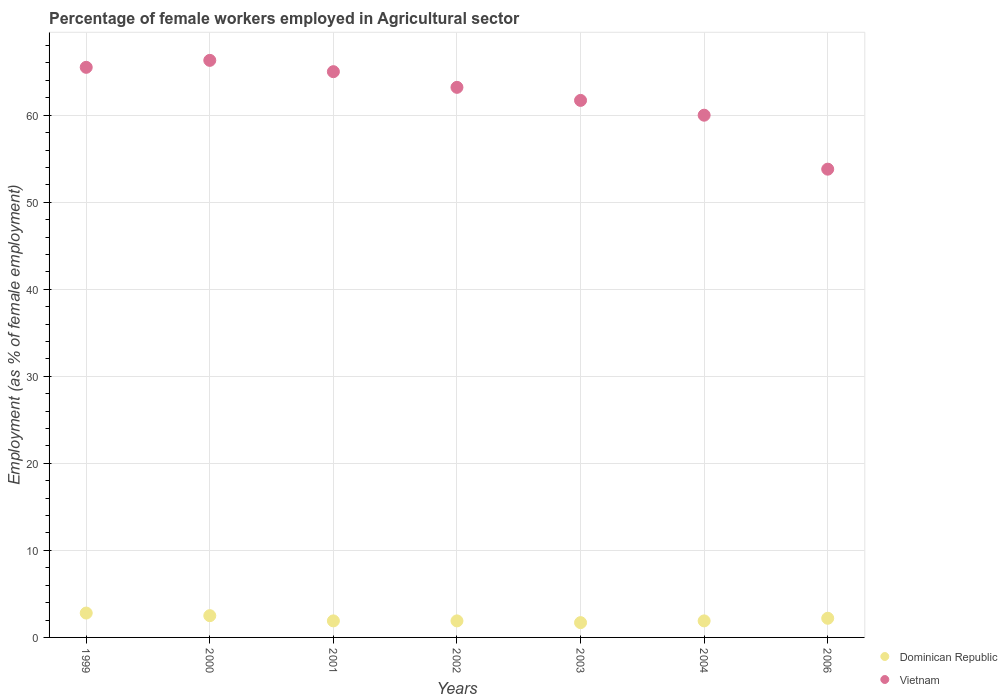How many different coloured dotlines are there?
Provide a short and direct response. 2. Is the number of dotlines equal to the number of legend labels?
Offer a terse response. Yes. What is the percentage of females employed in Agricultural sector in Dominican Republic in 2002?
Your answer should be compact. 1.9. Across all years, what is the maximum percentage of females employed in Agricultural sector in Dominican Republic?
Give a very brief answer. 2.8. Across all years, what is the minimum percentage of females employed in Agricultural sector in Vietnam?
Ensure brevity in your answer.  53.8. What is the total percentage of females employed in Agricultural sector in Dominican Republic in the graph?
Your answer should be very brief. 14.9. What is the difference between the percentage of females employed in Agricultural sector in Vietnam in 2000 and that in 2003?
Provide a succinct answer. 4.6. What is the difference between the percentage of females employed in Agricultural sector in Dominican Republic in 2006 and the percentage of females employed in Agricultural sector in Vietnam in 2003?
Your answer should be compact. -59.5. What is the average percentage of females employed in Agricultural sector in Dominican Republic per year?
Offer a very short reply. 2.13. In the year 2002, what is the difference between the percentage of females employed in Agricultural sector in Dominican Republic and percentage of females employed in Agricultural sector in Vietnam?
Provide a short and direct response. -61.3. What is the ratio of the percentage of females employed in Agricultural sector in Vietnam in 2003 to that in 2004?
Your answer should be compact. 1.03. What is the difference between the highest and the second highest percentage of females employed in Agricultural sector in Vietnam?
Make the answer very short. 0.8. What is the difference between the highest and the lowest percentage of females employed in Agricultural sector in Dominican Republic?
Keep it short and to the point. 1.1. In how many years, is the percentage of females employed in Agricultural sector in Dominican Republic greater than the average percentage of females employed in Agricultural sector in Dominican Republic taken over all years?
Provide a short and direct response. 3. Is the sum of the percentage of females employed in Agricultural sector in Vietnam in 1999 and 2006 greater than the maximum percentage of females employed in Agricultural sector in Dominican Republic across all years?
Offer a terse response. Yes. Is the percentage of females employed in Agricultural sector in Dominican Republic strictly greater than the percentage of females employed in Agricultural sector in Vietnam over the years?
Your answer should be compact. No. Is the percentage of females employed in Agricultural sector in Dominican Republic strictly less than the percentage of females employed in Agricultural sector in Vietnam over the years?
Your answer should be very brief. Yes. How many years are there in the graph?
Offer a very short reply. 7. Does the graph contain any zero values?
Ensure brevity in your answer.  No. Does the graph contain grids?
Ensure brevity in your answer.  Yes. Where does the legend appear in the graph?
Ensure brevity in your answer.  Bottom right. How many legend labels are there?
Ensure brevity in your answer.  2. What is the title of the graph?
Your response must be concise. Percentage of female workers employed in Agricultural sector. What is the label or title of the Y-axis?
Provide a short and direct response. Employment (as % of female employment). What is the Employment (as % of female employment) in Dominican Republic in 1999?
Ensure brevity in your answer.  2.8. What is the Employment (as % of female employment) of Vietnam in 1999?
Keep it short and to the point. 65.5. What is the Employment (as % of female employment) of Dominican Republic in 2000?
Your response must be concise. 2.5. What is the Employment (as % of female employment) in Vietnam in 2000?
Make the answer very short. 66.3. What is the Employment (as % of female employment) in Dominican Republic in 2001?
Your response must be concise. 1.9. What is the Employment (as % of female employment) of Dominican Republic in 2002?
Your answer should be very brief. 1.9. What is the Employment (as % of female employment) in Vietnam in 2002?
Your answer should be very brief. 63.2. What is the Employment (as % of female employment) of Dominican Republic in 2003?
Keep it short and to the point. 1.7. What is the Employment (as % of female employment) of Vietnam in 2003?
Ensure brevity in your answer.  61.7. What is the Employment (as % of female employment) of Dominican Republic in 2004?
Provide a short and direct response. 1.9. What is the Employment (as % of female employment) in Vietnam in 2004?
Offer a terse response. 60. What is the Employment (as % of female employment) of Dominican Republic in 2006?
Offer a terse response. 2.2. What is the Employment (as % of female employment) of Vietnam in 2006?
Your response must be concise. 53.8. Across all years, what is the maximum Employment (as % of female employment) of Dominican Republic?
Keep it short and to the point. 2.8. Across all years, what is the maximum Employment (as % of female employment) in Vietnam?
Make the answer very short. 66.3. Across all years, what is the minimum Employment (as % of female employment) in Dominican Republic?
Ensure brevity in your answer.  1.7. Across all years, what is the minimum Employment (as % of female employment) of Vietnam?
Keep it short and to the point. 53.8. What is the total Employment (as % of female employment) of Vietnam in the graph?
Provide a succinct answer. 435.5. What is the difference between the Employment (as % of female employment) in Dominican Republic in 1999 and that in 2001?
Provide a succinct answer. 0.9. What is the difference between the Employment (as % of female employment) in Vietnam in 1999 and that in 2002?
Your response must be concise. 2.3. What is the difference between the Employment (as % of female employment) in Dominican Republic in 1999 and that in 2003?
Ensure brevity in your answer.  1.1. What is the difference between the Employment (as % of female employment) of Vietnam in 1999 and that in 2003?
Ensure brevity in your answer.  3.8. What is the difference between the Employment (as % of female employment) in Vietnam in 1999 and that in 2006?
Ensure brevity in your answer.  11.7. What is the difference between the Employment (as % of female employment) of Dominican Republic in 2000 and that in 2001?
Offer a terse response. 0.6. What is the difference between the Employment (as % of female employment) in Vietnam in 2000 and that in 2001?
Your answer should be very brief. 1.3. What is the difference between the Employment (as % of female employment) of Vietnam in 2000 and that in 2002?
Keep it short and to the point. 3.1. What is the difference between the Employment (as % of female employment) in Dominican Republic in 2000 and that in 2003?
Keep it short and to the point. 0.8. What is the difference between the Employment (as % of female employment) in Dominican Republic in 2001 and that in 2002?
Give a very brief answer. 0. What is the difference between the Employment (as % of female employment) of Vietnam in 2001 and that in 2002?
Your answer should be compact. 1.8. What is the difference between the Employment (as % of female employment) of Dominican Republic in 2001 and that in 2003?
Offer a very short reply. 0.2. What is the difference between the Employment (as % of female employment) in Vietnam in 2001 and that in 2004?
Offer a terse response. 5. What is the difference between the Employment (as % of female employment) of Vietnam in 2001 and that in 2006?
Your response must be concise. 11.2. What is the difference between the Employment (as % of female employment) of Dominican Republic in 2002 and that in 2003?
Your answer should be very brief. 0.2. What is the difference between the Employment (as % of female employment) in Vietnam in 2002 and that in 2003?
Your response must be concise. 1.5. What is the difference between the Employment (as % of female employment) in Dominican Republic in 2002 and that in 2004?
Make the answer very short. 0. What is the difference between the Employment (as % of female employment) of Vietnam in 2002 and that in 2004?
Offer a very short reply. 3.2. What is the difference between the Employment (as % of female employment) of Vietnam in 2002 and that in 2006?
Your response must be concise. 9.4. What is the difference between the Employment (as % of female employment) in Dominican Republic in 2003 and that in 2004?
Your answer should be compact. -0.2. What is the difference between the Employment (as % of female employment) in Vietnam in 2003 and that in 2004?
Your answer should be compact. 1.7. What is the difference between the Employment (as % of female employment) in Dominican Republic in 2003 and that in 2006?
Make the answer very short. -0.5. What is the difference between the Employment (as % of female employment) in Vietnam in 2003 and that in 2006?
Offer a terse response. 7.9. What is the difference between the Employment (as % of female employment) of Dominican Republic in 2004 and that in 2006?
Provide a succinct answer. -0.3. What is the difference between the Employment (as % of female employment) of Dominican Republic in 1999 and the Employment (as % of female employment) of Vietnam in 2000?
Make the answer very short. -63.5. What is the difference between the Employment (as % of female employment) in Dominican Republic in 1999 and the Employment (as % of female employment) in Vietnam in 2001?
Your response must be concise. -62.2. What is the difference between the Employment (as % of female employment) of Dominican Republic in 1999 and the Employment (as % of female employment) of Vietnam in 2002?
Provide a short and direct response. -60.4. What is the difference between the Employment (as % of female employment) of Dominican Republic in 1999 and the Employment (as % of female employment) of Vietnam in 2003?
Provide a succinct answer. -58.9. What is the difference between the Employment (as % of female employment) of Dominican Republic in 1999 and the Employment (as % of female employment) of Vietnam in 2004?
Provide a short and direct response. -57.2. What is the difference between the Employment (as % of female employment) in Dominican Republic in 1999 and the Employment (as % of female employment) in Vietnam in 2006?
Ensure brevity in your answer.  -51. What is the difference between the Employment (as % of female employment) in Dominican Republic in 2000 and the Employment (as % of female employment) in Vietnam in 2001?
Your response must be concise. -62.5. What is the difference between the Employment (as % of female employment) of Dominican Republic in 2000 and the Employment (as % of female employment) of Vietnam in 2002?
Keep it short and to the point. -60.7. What is the difference between the Employment (as % of female employment) of Dominican Republic in 2000 and the Employment (as % of female employment) of Vietnam in 2003?
Provide a succinct answer. -59.2. What is the difference between the Employment (as % of female employment) in Dominican Republic in 2000 and the Employment (as % of female employment) in Vietnam in 2004?
Your answer should be very brief. -57.5. What is the difference between the Employment (as % of female employment) in Dominican Republic in 2000 and the Employment (as % of female employment) in Vietnam in 2006?
Provide a short and direct response. -51.3. What is the difference between the Employment (as % of female employment) in Dominican Republic in 2001 and the Employment (as % of female employment) in Vietnam in 2002?
Give a very brief answer. -61.3. What is the difference between the Employment (as % of female employment) in Dominican Republic in 2001 and the Employment (as % of female employment) in Vietnam in 2003?
Keep it short and to the point. -59.8. What is the difference between the Employment (as % of female employment) in Dominican Republic in 2001 and the Employment (as % of female employment) in Vietnam in 2004?
Give a very brief answer. -58.1. What is the difference between the Employment (as % of female employment) in Dominican Republic in 2001 and the Employment (as % of female employment) in Vietnam in 2006?
Offer a very short reply. -51.9. What is the difference between the Employment (as % of female employment) of Dominican Republic in 2002 and the Employment (as % of female employment) of Vietnam in 2003?
Your answer should be very brief. -59.8. What is the difference between the Employment (as % of female employment) in Dominican Republic in 2002 and the Employment (as % of female employment) in Vietnam in 2004?
Provide a succinct answer. -58.1. What is the difference between the Employment (as % of female employment) of Dominican Republic in 2002 and the Employment (as % of female employment) of Vietnam in 2006?
Your response must be concise. -51.9. What is the difference between the Employment (as % of female employment) of Dominican Republic in 2003 and the Employment (as % of female employment) of Vietnam in 2004?
Make the answer very short. -58.3. What is the difference between the Employment (as % of female employment) in Dominican Republic in 2003 and the Employment (as % of female employment) in Vietnam in 2006?
Provide a succinct answer. -52.1. What is the difference between the Employment (as % of female employment) in Dominican Republic in 2004 and the Employment (as % of female employment) in Vietnam in 2006?
Your answer should be compact. -51.9. What is the average Employment (as % of female employment) of Dominican Republic per year?
Provide a succinct answer. 2.13. What is the average Employment (as % of female employment) in Vietnam per year?
Your answer should be compact. 62.21. In the year 1999, what is the difference between the Employment (as % of female employment) of Dominican Republic and Employment (as % of female employment) of Vietnam?
Your answer should be very brief. -62.7. In the year 2000, what is the difference between the Employment (as % of female employment) of Dominican Republic and Employment (as % of female employment) of Vietnam?
Provide a succinct answer. -63.8. In the year 2001, what is the difference between the Employment (as % of female employment) of Dominican Republic and Employment (as % of female employment) of Vietnam?
Ensure brevity in your answer.  -63.1. In the year 2002, what is the difference between the Employment (as % of female employment) of Dominican Republic and Employment (as % of female employment) of Vietnam?
Ensure brevity in your answer.  -61.3. In the year 2003, what is the difference between the Employment (as % of female employment) in Dominican Republic and Employment (as % of female employment) in Vietnam?
Keep it short and to the point. -60. In the year 2004, what is the difference between the Employment (as % of female employment) of Dominican Republic and Employment (as % of female employment) of Vietnam?
Make the answer very short. -58.1. In the year 2006, what is the difference between the Employment (as % of female employment) in Dominican Republic and Employment (as % of female employment) in Vietnam?
Offer a very short reply. -51.6. What is the ratio of the Employment (as % of female employment) in Dominican Republic in 1999 to that in 2000?
Offer a terse response. 1.12. What is the ratio of the Employment (as % of female employment) in Vietnam in 1999 to that in 2000?
Offer a very short reply. 0.99. What is the ratio of the Employment (as % of female employment) of Dominican Republic in 1999 to that in 2001?
Make the answer very short. 1.47. What is the ratio of the Employment (as % of female employment) of Vietnam in 1999 to that in 2001?
Provide a short and direct response. 1.01. What is the ratio of the Employment (as % of female employment) in Dominican Republic in 1999 to that in 2002?
Your answer should be very brief. 1.47. What is the ratio of the Employment (as % of female employment) of Vietnam in 1999 to that in 2002?
Offer a very short reply. 1.04. What is the ratio of the Employment (as % of female employment) in Dominican Republic in 1999 to that in 2003?
Provide a succinct answer. 1.65. What is the ratio of the Employment (as % of female employment) of Vietnam in 1999 to that in 2003?
Ensure brevity in your answer.  1.06. What is the ratio of the Employment (as % of female employment) in Dominican Republic in 1999 to that in 2004?
Give a very brief answer. 1.47. What is the ratio of the Employment (as % of female employment) in Vietnam in 1999 to that in 2004?
Offer a terse response. 1.09. What is the ratio of the Employment (as % of female employment) of Dominican Republic in 1999 to that in 2006?
Offer a very short reply. 1.27. What is the ratio of the Employment (as % of female employment) in Vietnam in 1999 to that in 2006?
Provide a short and direct response. 1.22. What is the ratio of the Employment (as % of female employment) of Dominican Republic in 2000 to that in 2001?
Keep it short and to the point. 1.32. What is the ratio of the Employment (as % of female employment) of Vietnam in 2000 to that in 2001?
Give a very brief answer. 1.02. What is the ratio of the Employment (as % of female employment) of Dominican Republic in 2000 to that in 2002?
Ensure brevity in your answer.  1.32. What is the ratio of the Employment (as % of female employment) of Vietnam in 2000 to that in 2002?
Your answer should be very brief. 1.05. What is the ratio of the Employment (as % of female employment) in Dominican Republic in 2000 to that in 2003?
Keep it short and to the point. 1.47. What is the ratio of the Employment (as % of female employment) in Vietnam in 2000 to that in 2003?
Offer a terse response. 1.07. What is the ratio of the Employment (as % of female employment) of Dominican Republic in 2000 to that in 2004?
Provide a succinct answer. 1.32. What is the ratio of the Employment (as % of female employment) in Vietnam in 2000 to that in 2004?
Keep it short and to the point. 1.1. What is the ratio of the Employment (as % of female employment) in Dominican Republic in 2000 to that in 2006?
Keep it short and to the point. 1.14. What is the ratio of the Employment (as % of female employment) in Vietnam in 2000 to that in 2006?
Ensure brevity in your answer.  1.23. What is the ratio of the Employment (as % of female employment) in Vietnam in 2001 to that in 2002?
Give a very brief answer. 1.03. What is the ratio of the Employment (as % of female employment) of Dominican Republic in 2001 to that in 2003?
Ensure brevity in your answer.  1.12. What is the ratio of the Employment (as % of female employment) of Vietnam in 2001 to that in 2003?
Your response must be concise. 1.05. What is the ratio of the Employment (as % of female employment) in Dominican Republic in 2001 to that in 2004?
Keep it short and to the point. 1. What is the ratio of the Employment (as % of female employment) of Vietnam in 2001 to that in 2004?
Your response must be concise. 1.08. What is the ratio of the Employment (as % of female employment) of Dominican Republic in 2001 to that in 2006?
Give a very brief answer. 0.86. What is the ratio of the Employment (as % of female employment) in Vietnam in 2001 to that in 2006?
Offer a terse response. 1.21. What is the ratio of the Employment (as % of female employment) in Dominican Republic in 2002 to that in 2003?
Your response must be concise. 1.12. What is the ratio of the Employment (as % of female employment) of Vietnam in 2002 to that in 2003?
Give a very brief answer. 1.02. What is the ratio of the Employment (as % of female employment) of Vietnam in 2002 to that in 2004?
Make the answer very short. 1.05. What is the ratio of the Employment (as % of female employment) of Dominican Republic in 2002 to that in 2006?
Your answer should be compact. 0.86. What is the ratio of the Employment (as % of female employment) in Vietnam in 2002 to that in 2006?
Give a very brief answer. 1.17. What is the ratio of the Employment (as % of female employment) in Dominican Republic in 2003 to that in 2004?
Your response must be concise. 0.89. What is the ratio of the Employment (as % of female employment) of Vietnam in 2003 to that in 2004?
Keep it short and to the point. 1.03. What is the ratio of the Employment (as % of female employment) of Dominican Republic in 2003 to that in 2006?
Offer a very short reply. 0.77. What is the ratio of the Employment (as % of female employment) in Vietnam in 2003 to that in 2006?
Ensure brevity in your answer.  1.15. What is the ratio of the Employment (as % of female employment) of Dominican Republic in 2004 to that in 2006?
Provide a short and direct response. 0.86. What is the ratio of the Employment (as % of female employment) of Vietnam in 2004 to that in 2006?
Ensure brevity in your answer.  1.12. What is the difference between the highest and the second highest Employment (as % of female employment) in Dominican Republic?
Ensure brevity in your answer.  0.3. What is the difference between the highest and the second highest Employment (as % of female employment) of Vietnam?
Provide a short and direct response. 0.8. What is the difference between the highest and the lowest Employment (as % of female employment) of Vietnam?
Offer a terse response. 12.5. 